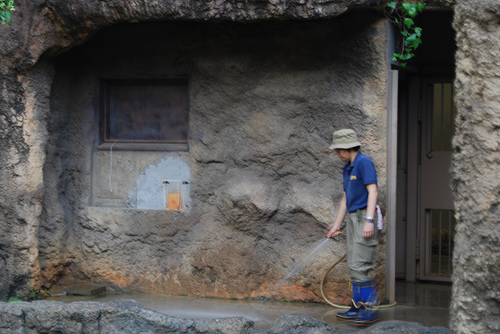<image>
Can you confirm if the wall is behind the woman? Yes. From this viewpoint, the wall is positioned behind the woman, with the woman partially or fully occluding the wall. 